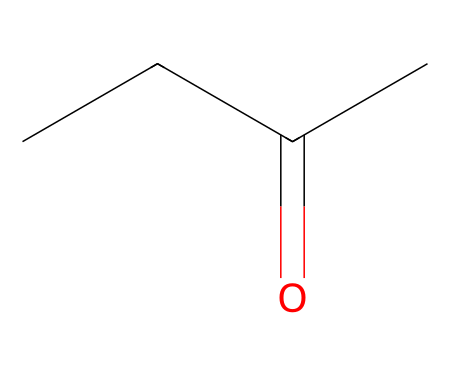What is the name of this chemical? The chemical represented by the SMILES CCC(=O)C is methyl ethyl ketone. The structure shows a ketone functional group indicated by the carbonyl (C=O) and the name corresponds to the presence of a methyl group and an ethyl group on either side of the carbonyl.
Answer: methyl ethyl ketone How many carbon atoms are in methyl ethyl ketone? Analyzing the SMILES representation, there are four carbon atoms present: two from the ethyl group (C-C), one from the carbonyl (C=O), and one from the methyl group (C).
Answer: four What functional group is present in this compound? The presence of the carbonyl group (C=O) indicates that this compound belongs to the ketone functional group. In ketones, the carbonyl carbon is connected to two other carbon atoms.
Answer: carbonyl What is the molecular formula of methyl ethyl ketone? By counting the elements from the structure: four carbon (C), eight hydrogen (H), and one oxygen (O), the molecular formula is determined to be C4H8O.
Answer: C4H8O Is this chemical a simple ketone, and why? Yes, this is a simple ketone because it has a straightforward structure consisting of a carbonyl group bonded to two alkyl groups (ethyl and methyl), which fits the general definition of a ketone.
Answer: yes How many hydrogen atoms are attached to the carbonyl carbon? In the structure of methyl ethyl ketone, the carbonyl carbon is bonded to one alkyl group (ethyl) and one carbon from the methyl group, which means it does not have any hydrogen atoms attached directly to it.
Answer: zero 